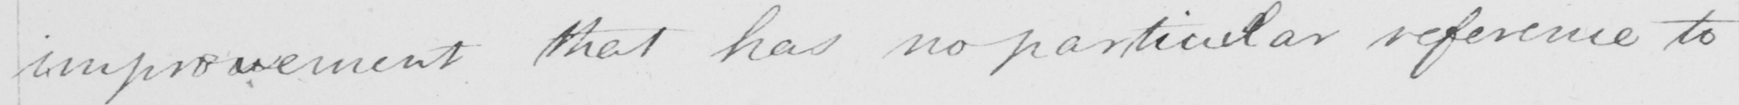What text is written in this handwritten line? improvement that has no particular reference to 